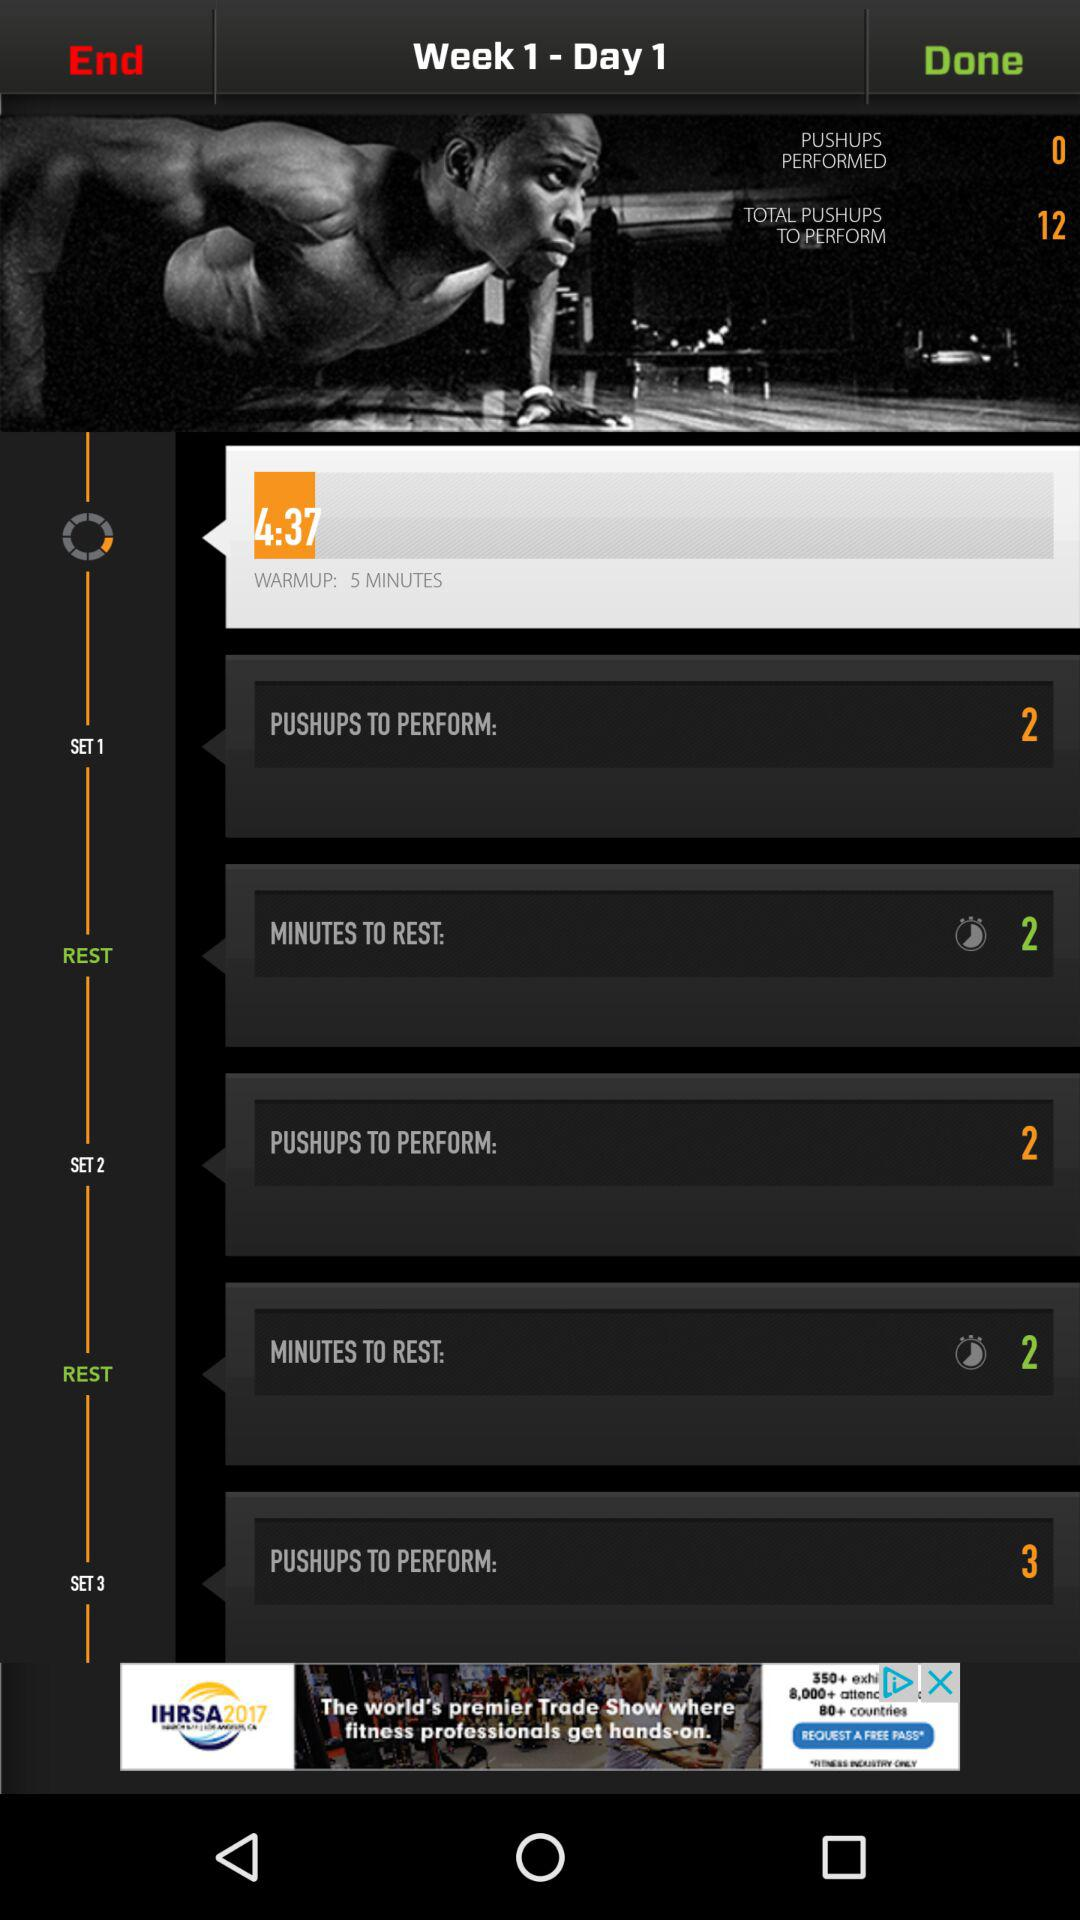With which set are the 3 minutes associated? The 3 minutes are associated with set 3. 